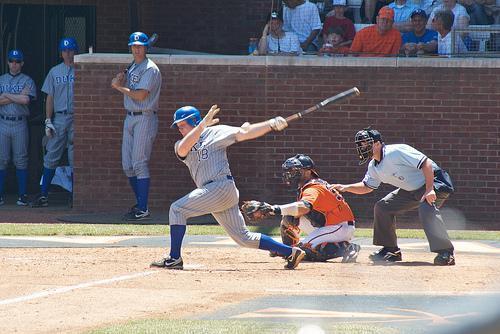How many people are wearing face masks?
Give a very brief answer. 2. How many people are wearing orange shirts?
Give a very brief answer. 1. 